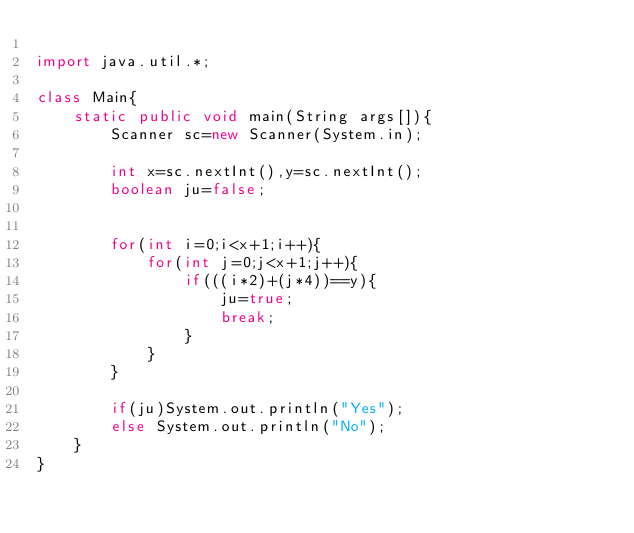<code> <loc_0><loc_0><loc_500><loc_500><_Java_>
import java.util.*;

class Main{
	static public void main(String args[]){
		Scanner sc=new Scanner(System.in);
		
		int x=sc.nextInt(),y=sc.nextInt();
		boolean ju=false;

		
		for(int i=0;i<x+1;i++){
			for(int j=0;j<x+1;j++){
				if(((i*2)+(j*4))==y){
					ju=true;
					break;
				}
			}
		}
		
		if(ju)System.out.println("Yes");
		else System.out.println("No");
	}
}</code> 